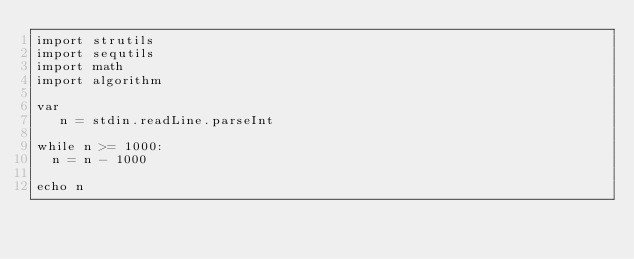Convert code to text. <code><loc_0><loc_0><loc_500><loc_500><_Nim_>import strutils
import sequtils
import math
import algorithm

var
   n = stdin.readLine.parseInt

while n >= 1000:
  n = n - 1000

echo n
</code> 